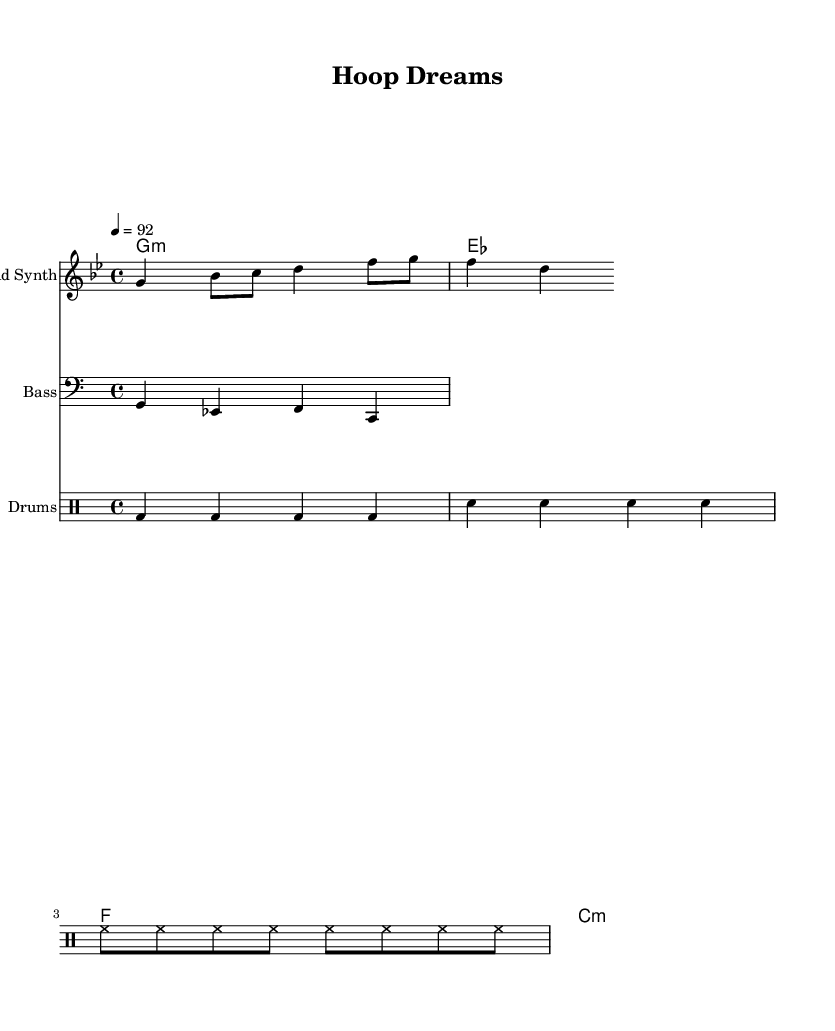What is the key signature of this music? The key signature is G minor, which has two flats: B flat and E flat. This can be determined by looking for the key signature markings at the beginning of the staff.
Answer: G minor What is the time signature in this piece? The time signature is 4/4, meaning there are four beats per measure and the quarter note gets one beat. This information is typically notated at the beginning of the music.
Answer: 4/4 What is the tempo marking for this composition? The tempo marking is "4 = 92," indicating that there are 92 beats per minute at quarter note speed. It's shown at the top of the score to guide the performance speed.
Answer: 92 How many chords are indicated in the chord progression? There are four chords indicated in the chord progression. This can be seen by counting the distinct chord symbols listed in the chordNames section of the score.
Answer: Four What instruments are featured in this score? The featured instruments in this score are Lead Synth, Bass, and Drums. Each instrument is represented on its own staff, making them easy to identify.
Answer: Lead Synth, Bass, Drums Which chord appears first in the chord progression? The first chord in the progression is G minor. This is found by checking the order of the chord symbols listed in the chordNames section.
Answer: G minor What type of music is this score representative of? This score represents Hip Hop music, which is characterized by its rhythmic style and emphasis on beat. The structure and instruments suggest it's aimed at a hip-hop audience.
Answer: Hip Hop 